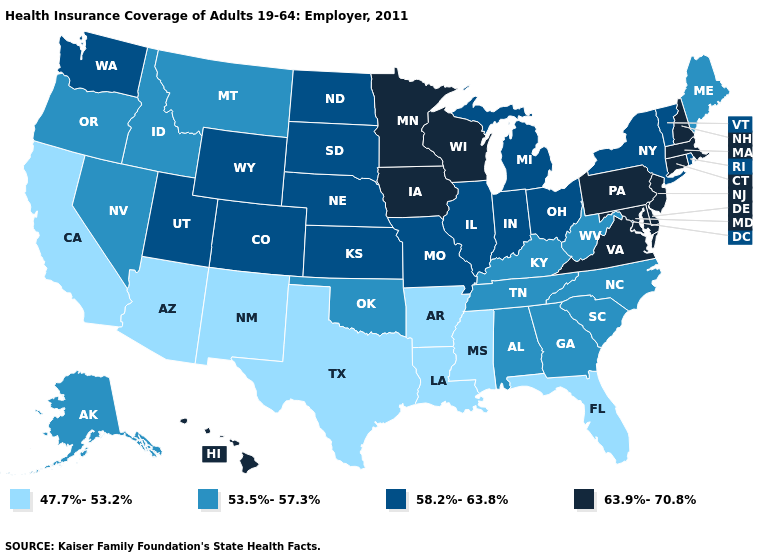Name the states that have a value in the range 63.9%-70.8%?
Short answer required. Connecticut, Delaware, Hawaii, Iowa, Maryland, Massachusetts, Minnesota, New Hampshire, New Jersey, Pennsylvania, Virginia, Wisconsin. Name the states that have a value in the range 63.9%-70.8%?
Short answer required. Connecticut, Delaware, Hawaii, Iowa, Maryland, Massachusetts, Minnesota, New Hampshire, New Jersey, Pennsylvania, Virginia, Wisconsin. Among the states that border Kentucky , does Ohio have the highest value?
Quick response, please. No. Which states hav the highest value in the South?
Write a very short answer. Delaware, Maryland, Virginia. Name the states that have a value in the range 63.9%-70.8%?
Short answer required. Connecticut, Delaware, Hawaii, Iowa, Maryland, Massachusetts, Minnesota, New Hampshire, New Jersey, Pennsylvania, Virginia, Wisconsin. Name the states that have a value in the range 47.7%-53.2%?
Give a very brief answer. Arizona, Arkansas, California, Florida, Louisiana, Mississippi, New Mexico, Texas. Which states have the highest value in the USA?
Concise answer only. Connecticut, Delaware, Hawaii, Iowa, Maryland, Massachusetts, Minnesota, New Hampshire, New Jersey, Pennsylvania, Virginia, Wisconsin. What is the highest value in the Northeast ?
Concise answer only. 63.9%-70.8%. What is the value of Maine?
Keep it brief. 53.5%-57.3%. What is the highest value in states that border Arkansas?
Short answer required. 58.2%-63.8%. Name the states that have a value in the range 53.5%-57.3%?
Be succinct. Alabama, Alaska, Georgia, Idaho, Kentucky, Maine, Montana, Nevada, North Carolina, Oklahoma, Oregon, South Carolina, Tennessee, West Virginia. Name the states that have a value in the range 47.7%-53.2%?
Quick response, please. Arizona, Arkansas, California, Florida, Louisiana, Mississippi, New Mexico, Texas. What is the highest value in states that border New Hampshire?
Give a very brief answer. 63.9%-70.8%. What is the value of Arizona?
Keep it brief. 47.7%-53.2%. Does Massachusetts have the highest value in the USA?
Answer briefly. Yes. 